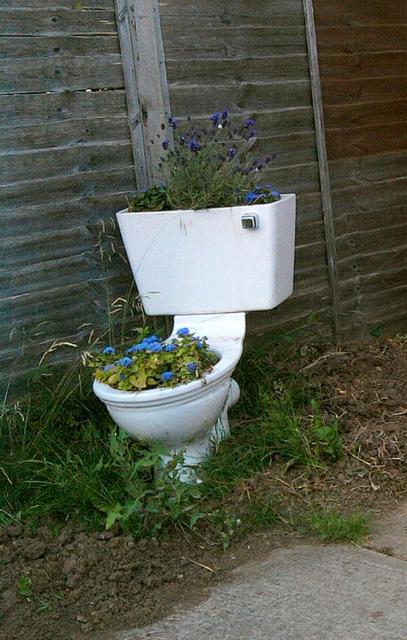What is position under the toilet seat?
Keep it brief. Grass. Is the toilet indoors or out?
Write a very short answer. Out. Are there many leaves on the ground?
Keep it brief. No. Which side is the handle?
Write a very short answer. Right. Is this innovative?
Quick response, please. Yes. Is that a banana tree in the back?
Keep it brief. No. What is the toilet being used for?
Give a very brief answer. Planter. How many potted plants do you see?
Give a very brief answer. 2. How many flowers are in the bushes?
Keep it brief. 20. 